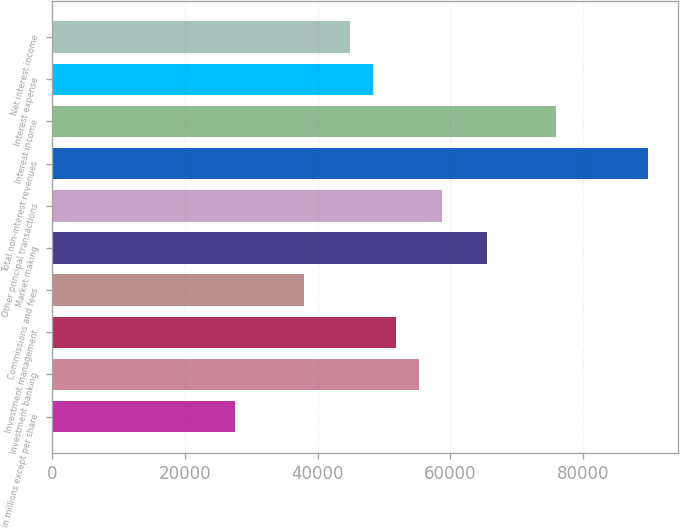Convert chart to OTSL. <chart><loc_0><loc_0><loc_500><loc_500><bar_chart><fcel>in millions except per share<fcel>Investment banking<fcel>Investment management<fcel>Commissions and fees<fcel>Market making<fcel>Other principal transactions<fcel>Total non-interest revenues<fcel>Interest income<fcel>Interest expense<fcel>Net interest income<nl><fcel>27625.8<fcel>55234.5<fcel>51783.4<fcel>37979.1<fcel>65587.8<fcel>58685.6<fcel>89745.4<fcel>75941.1<fcel>48332.3<fcel>44881.2<nl></chart> 